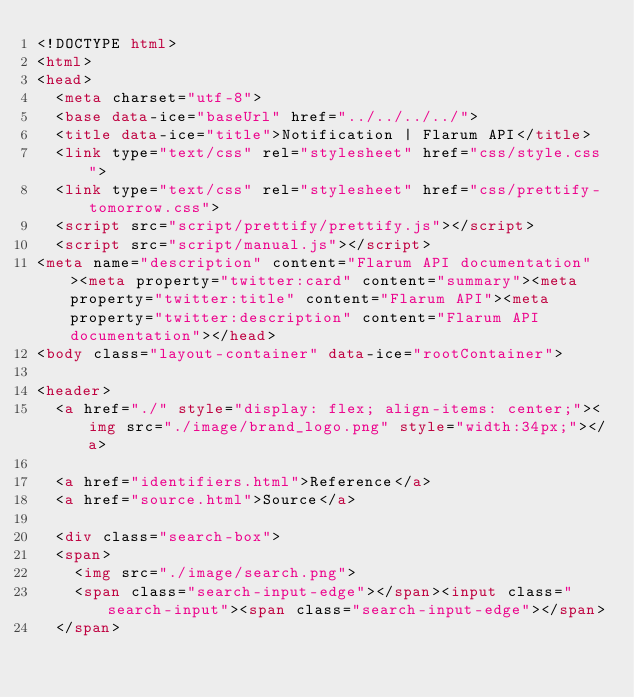Convert code to text. <code><loc_0><loc_0><loc_500><loc_500><_HTML_><!DOCTYPE html>
<html>
<head>
  <meta charset="utf-8">
  <base data-ice="baseUrl" href="../../../../">
  <title data-ice="title">Notification | Flarum API</title>
  <link type="text/css" rel="stylesheet" href="css/style.css">
  <link type="text/css" rel="stylesheet" href="css/prettify-tomorrow.css">
  <script src="script/prettify/prettify.js"></script>
  <script src="script/manual.js"></script>
<meta name="description" content="Flarum API documentation"><meta property="twitter:card" content="summary"><meta property="twitter:title" content="Flarum API"><meta property="twitter:description" content="Flarum API documentation"></head>
<body class="layout-container" data-ice="rootContainer">

<header>
  <a href="./" style="display: flex; align-items: center;"><img src="./image/brand_logo.png" style="width:34px;"></a>
  
  <a href="identifiers.html">Reference</a>
  <a href="source.html">Source</a>
  
  <div class="search-box">
  <span>
    <img src="./image/search.png">
    <span class="search-input-edge"></span><input class="search-input"><span class="search-input-edge"></span>
  </span></code> 